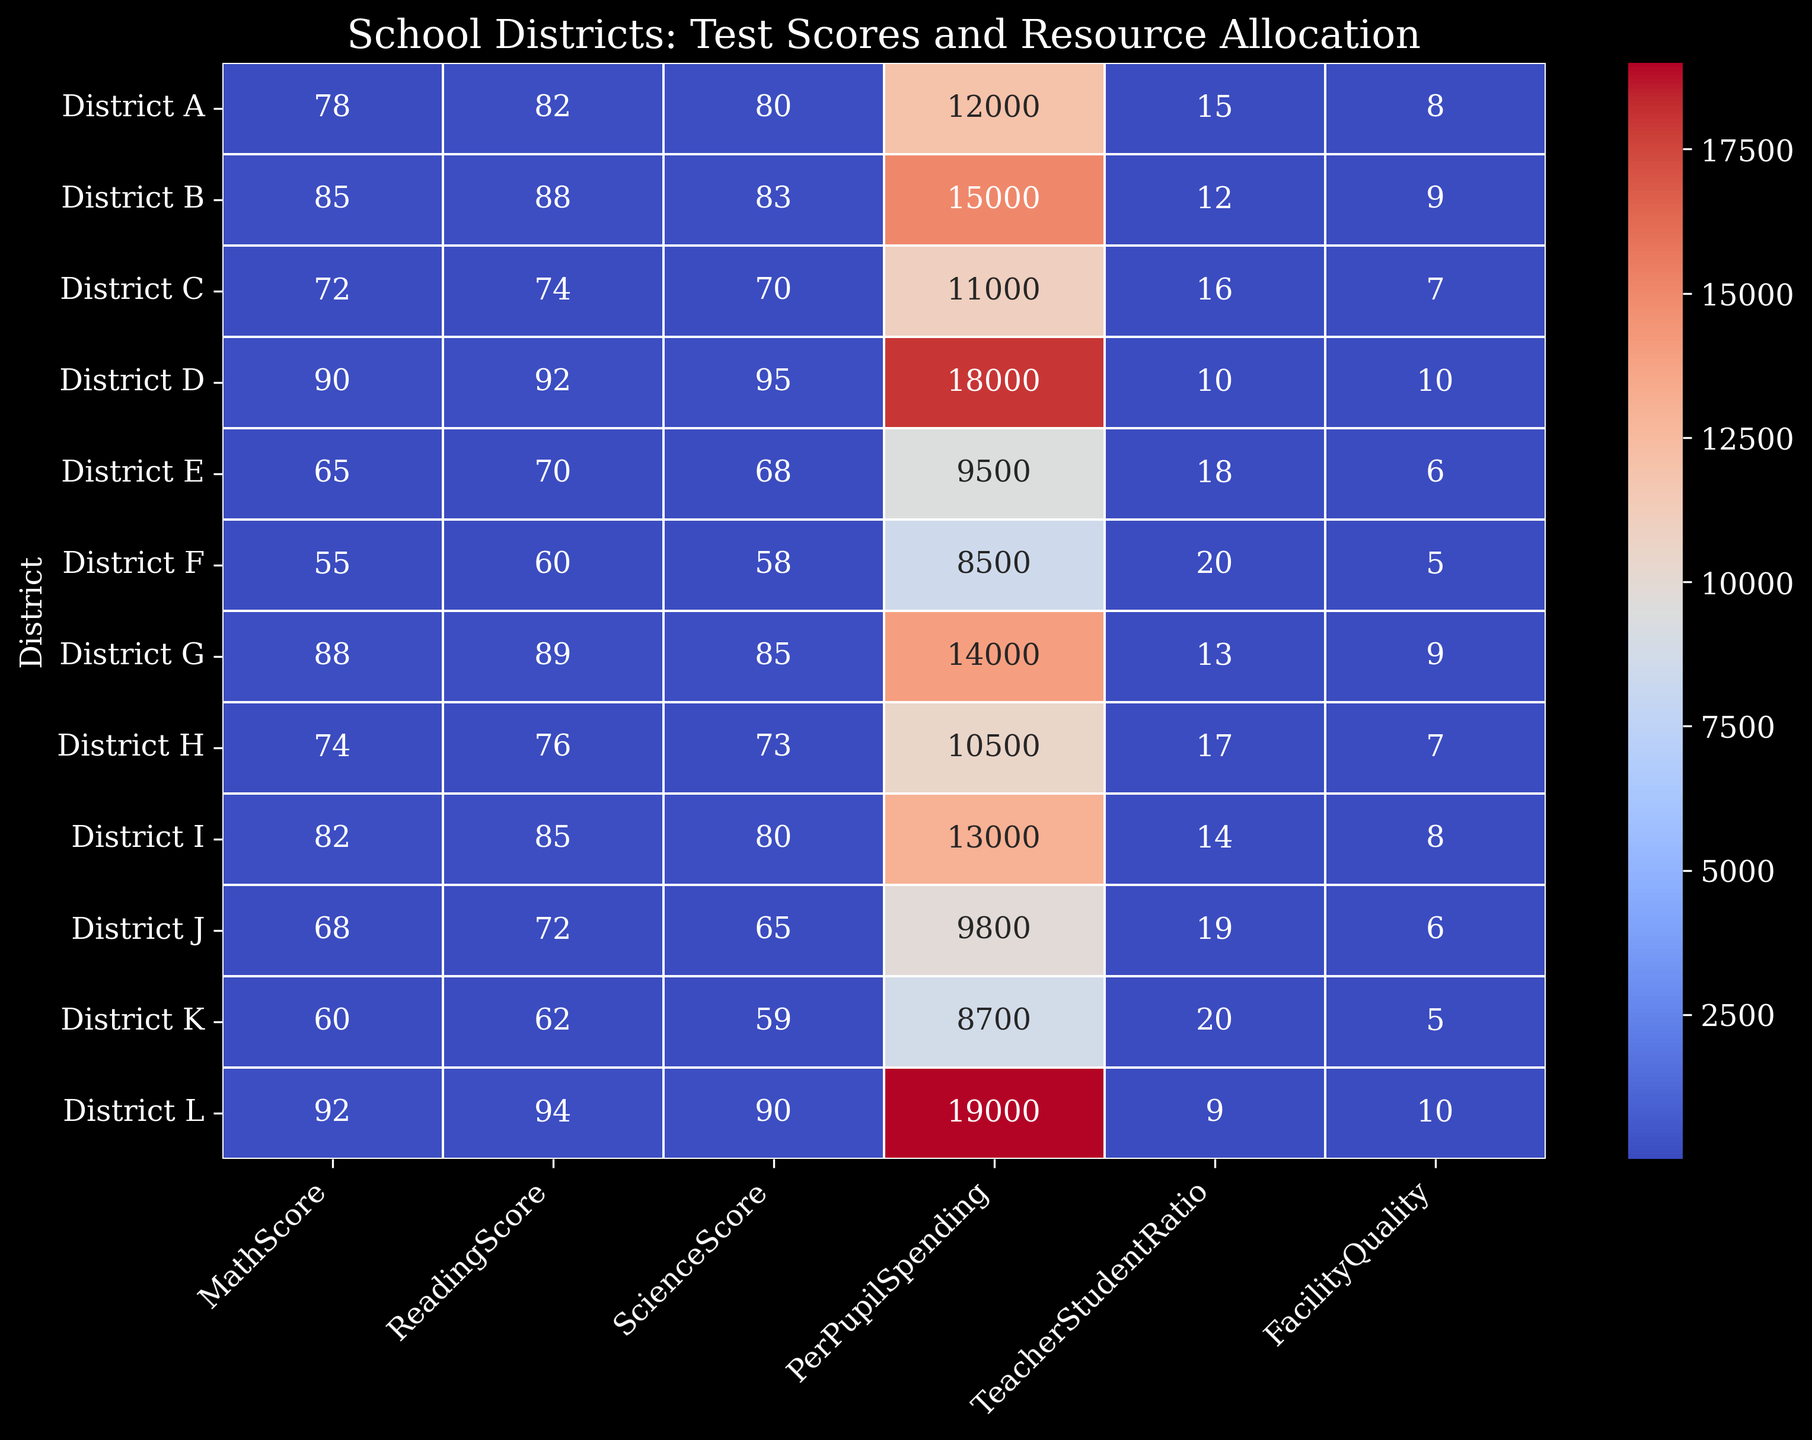What district has the highest MathScore? The heatmap shows the MathScores for each district. The district with the highest value in the MathScore column is 92, which belongs to District L.
Answer: District L Which district has the lowest PerPupilSpending? The heatmap shows the PerPupilSpending for each district. The district with the lowest value in this column is 8500, which corresponds to District F.
Answer: District F Which district has a better TeacherStudentRatio, District D or District G? Comparing the TeacherStudentRatio values in the heatmap, District D has a ratio of 10 while District G has a ratio of 13. A lower ratio indicates better individual attention, so District D has a better ratio.
Answer: District D What is the average ReadingScore of Districts C, E, and G? Summing the ReadingScores for Districts C, E, and G yields 74 + 70 + 89 = 233. The average is then 233 / 3 = 77.67.
Answer: 77.67 What is the sum of MathScores for Districts A, J, and K? The MathScores for Districts A, J, and K are 78, 68, and 60 respectively. Adding these together: 78 + 68 + 60 = 206.
Answer: 206 Which district has the best FacilityQuality and what is its PerPupilSpending? The best FacilityQuality score is 10, shared by Districts D and L. District D has a PerPupilSpending of 18000 while District L has 19000.
Answer: District D, District L (PerPupilSpending 18000, 19000) Which district has a higher ScienceScore, District A or District I? The heatmap indicates that District A has a ScienceScore of 80 and District I has a ScienceScore of 80. Therefore, both have equal ScienceScores.
Answer: Both equal How many districts have a FacilityQuality score of 7 or higher? By examining the FacilityQuality column in the heatmap, Districts A (8), B (9), D (10), G (9), H (7), I (8), and L (10) meet the criteria. Counting these districts gives 7.
Answer: 7 What's the difference in ReadingScore between District H and District J? District H has a ReadingScore of 76, and District J has 72. The difference is 76 - 72 = 4.
Answer: 4 What is the average TeacherStudentRatio of the districts with a MathScore above 80? Districts with a MathScore above 80 are B, D, G, I, and L. Their TeacherStudentRatios are 12, 10, 13, 14, and 9 respectively. The sum is 58, so the average is 58 / 5 = 11.6.
Answer: 11.6 